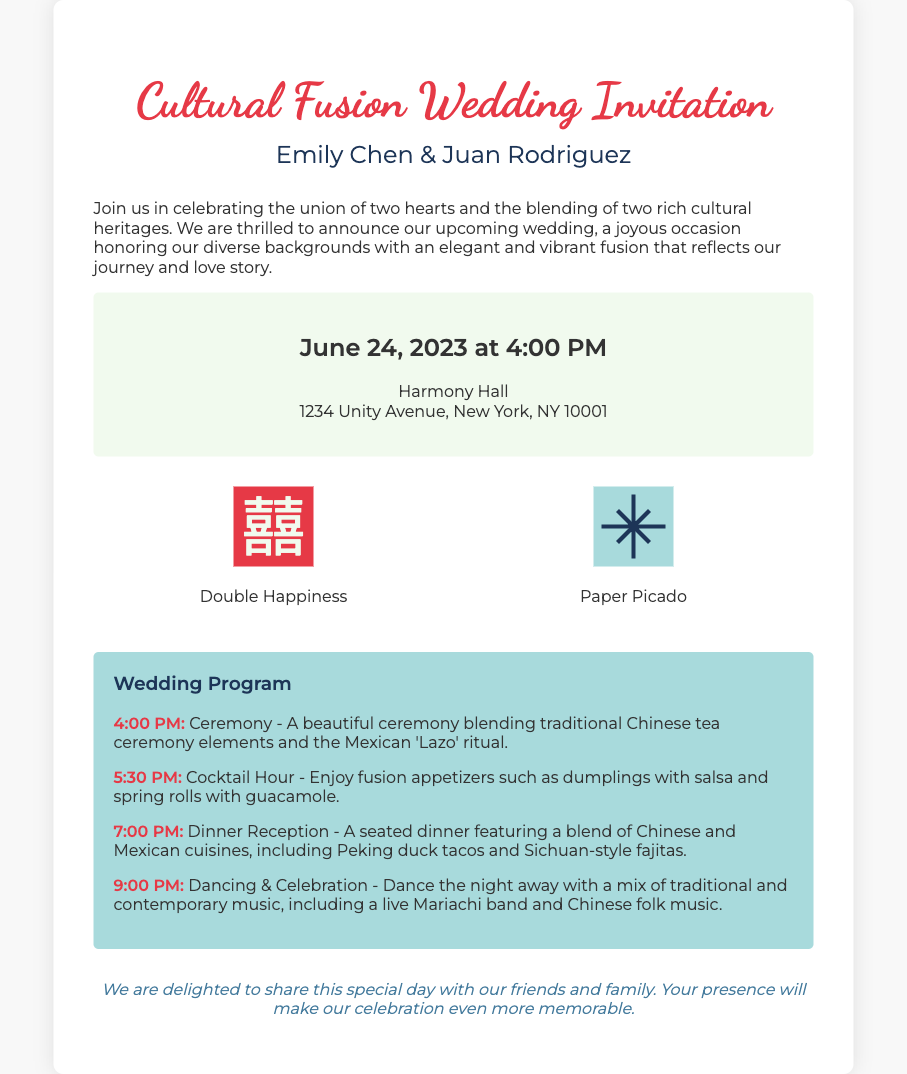What are the names of the couple? The names of the couple are mentioned in the header section of the invitation.
Answer: Emily Chen & Juan Rodriguez When is the wedding date? The wedding date is specified in the date-venue section of the document.
Answer: June 24, 2023 What time does the ceremony start? The start time of the ceremony is indicated in the program section.
Answer: 4:00 PM What cultural practices are included in the ceremony? The ceremony includes elements from two cultural practices mentioned in the description.
Answer: Chinese tea ceremony and Mexican 'Lazo' ritual What type of cuisine will be served at dinner? The type of cuisine being served is outlined in the program section of the invitation.
Answer: Chinese and Mexican cuisines What is the primary theme of this wedding invitation? The theme is explicitly stated at the top of the document and reflects cultural aspects.
Answer: Cultural Fusion How many symbols are represented in the design elements? The number of symbols can be counted from the design elements section.
Answer: Two What type of music will be played during the celebration? The type of music is described in the program of the invitation.
Answer: Traditional and contemporary music 